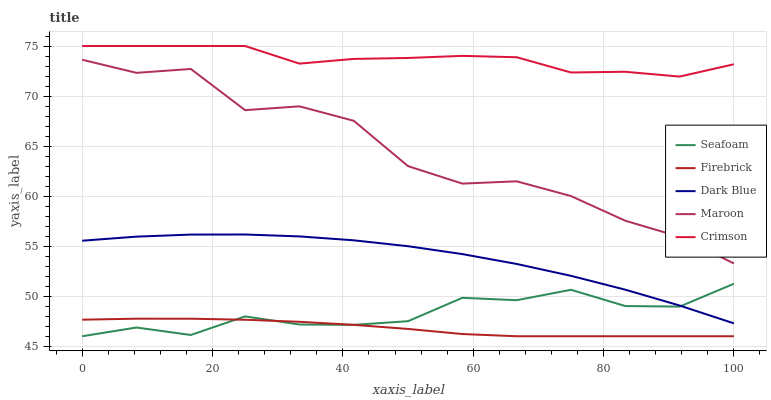Does Firebrick have the minimum area under the curve?
Answer yes or no. Yes. Does Crimson have the maximum area under the curve?
Answer yes or no. Yes. Does Dark Blue have the minimum area under the curve?
Answer yes or no. No. Does Dark Blue have the maximum area under the curve?
Answer yes or no. No. Is Firebrick the smoothest?
Answer yes or no. Yes. Is Maroon the roughest?
Answer yes or no. Yes. Is Dark Blue the smoothest?
Answer yes or no. No. Is Dark Blue the roughest?
Answer yes or no. No. Does Firebrick have the lowest value?
Answer yes or no. Yes. Does Dark Blue have the lowest value?
Answer yes or no. No. Does Crimson have the highest value?
Answer yes or no. Yes. Does Dark Blue have the highest value?
Answer yes or no. No. Is Firebrick less than Crimson?
Answer yes or no. Yes. Is Maroon greater than Firebrick?
Answer yes or no. Yes. Does Seafoam intersect Dark Blue?
Answer yes or no. Yes. Is Seafoam less than Dark Blue?
Answer yes or no. No. Is Seafoam greater than Dark Blue?
Answer yes or no. No. Does Firebrick intersect Crimson?
Answer yes or no. No. 